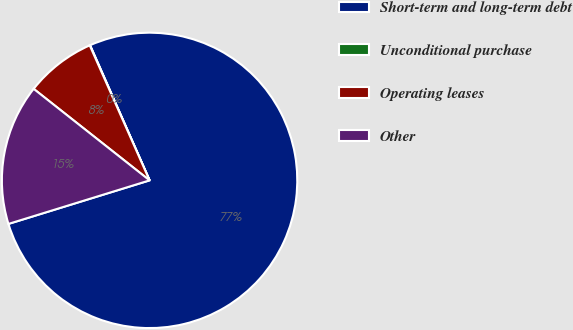Convert chart. <chart><loc_0><loc_0><loc_500><loc_500><pie_chart><fcel>Short-term and long-term debt<fcel>Unconditional purchase<fcel>Operating leases<fcel>Other<nl><fcel>76.84%<fcel>0.04%<fcel>7.72%<fcel>15.4%<nl></chart> 